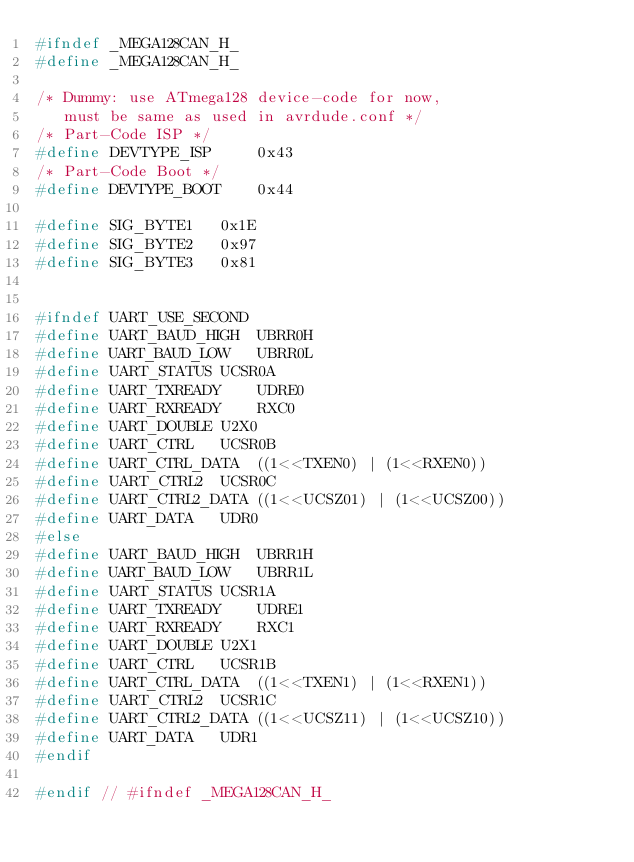<code> <loc_0><loc_0><loc_500><loc_500><_C_>#ifndef _MEGA128CAN_H_
#define _MEGA128CAN_H_

/* Dummy: use ATmega128 device-code for now, 
   must be same as used in avrdude.conf */
/* Part-Code ISP */
#define DEVTYPE_ISP     0x43
/* Part-Code Boot */
#define DEVTYPE_BOOT    0x44

#define SIG_BYTE1	0x1E
#define SIG_BYTE2	0x97
#define SIG_BYTE3	0x81


#ifndef UART_USE_SECOND
#define UART_BAUD_HIGH	UBRR0H
#define UART_BAUD_LOW	UBRR0L
#define UART_STATUS	UCSR0A
#define UART_TXREADY	UDRE0
#define UART_RXREADY	RXC0
#define UART_DOUBLE	U2X0
#define UART_CTRL	UCSR0B
#define UART_CTRL_DATA	((1<<TXEN0) | (1<<RXEN0))
#define UART_CTRL2	UCSR0C
#define UART_CTRL2_DATA	((1<<UCSZ01) | (1<<UCSZ00))
#define UART_DATA	UDR0
#else
#define UART_BAUD_HIGH	UBRR1H
#define UART_BAUD_LOW	UBRR1L
#define UART_STATUS	UCSR1A
#define UART_TXREADY	UDRE1
#define UART_RXREADY	RXC1
#define UART_DOUBLE	U2X1
#define UART_CTRL	UCSR1B
#define UART_CTRL_DATA	((1<<TXEN1) | (1<<RXEN1))
#define UART_CTRL2	UCSR1C
#define UART_CTRL2_DATA	((1<<UCSZ11) | (1<<UCSZ10))
#define UART_DATA	UDR1
#endif

#endif // #ifndef _MEGA128CAN_H_
</code> 